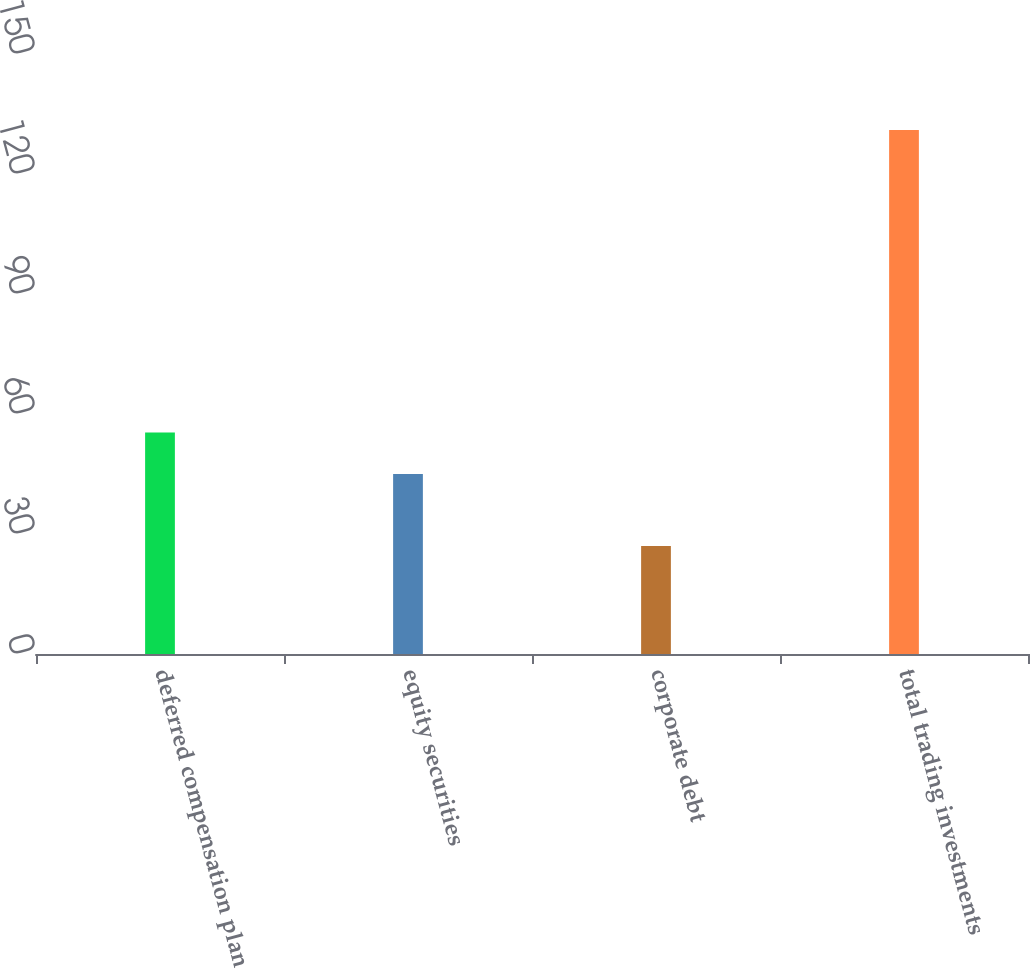Convert chart. <chart><loc_0><loc_0><loc_500><loc_500><bar_chart><fcel>deferred compensation plan<fcel>equity securities<fcel>corporate debt<fcel>total trading investments<nl><fcel>55.4<fcel>45<fcel>27<fcel>131<nl></chart> 